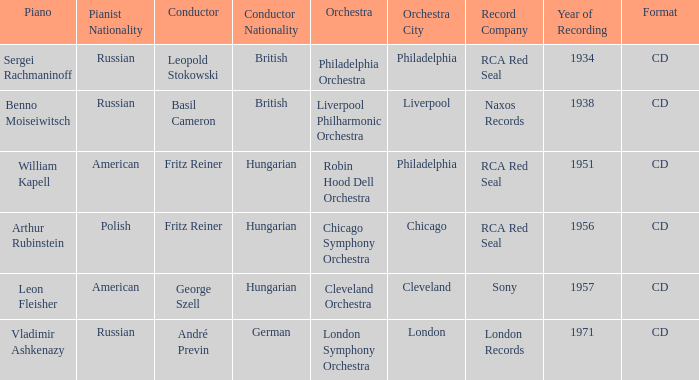Where is the orchestra when the year of recording is 1934? Philadelphia Orchestra. 